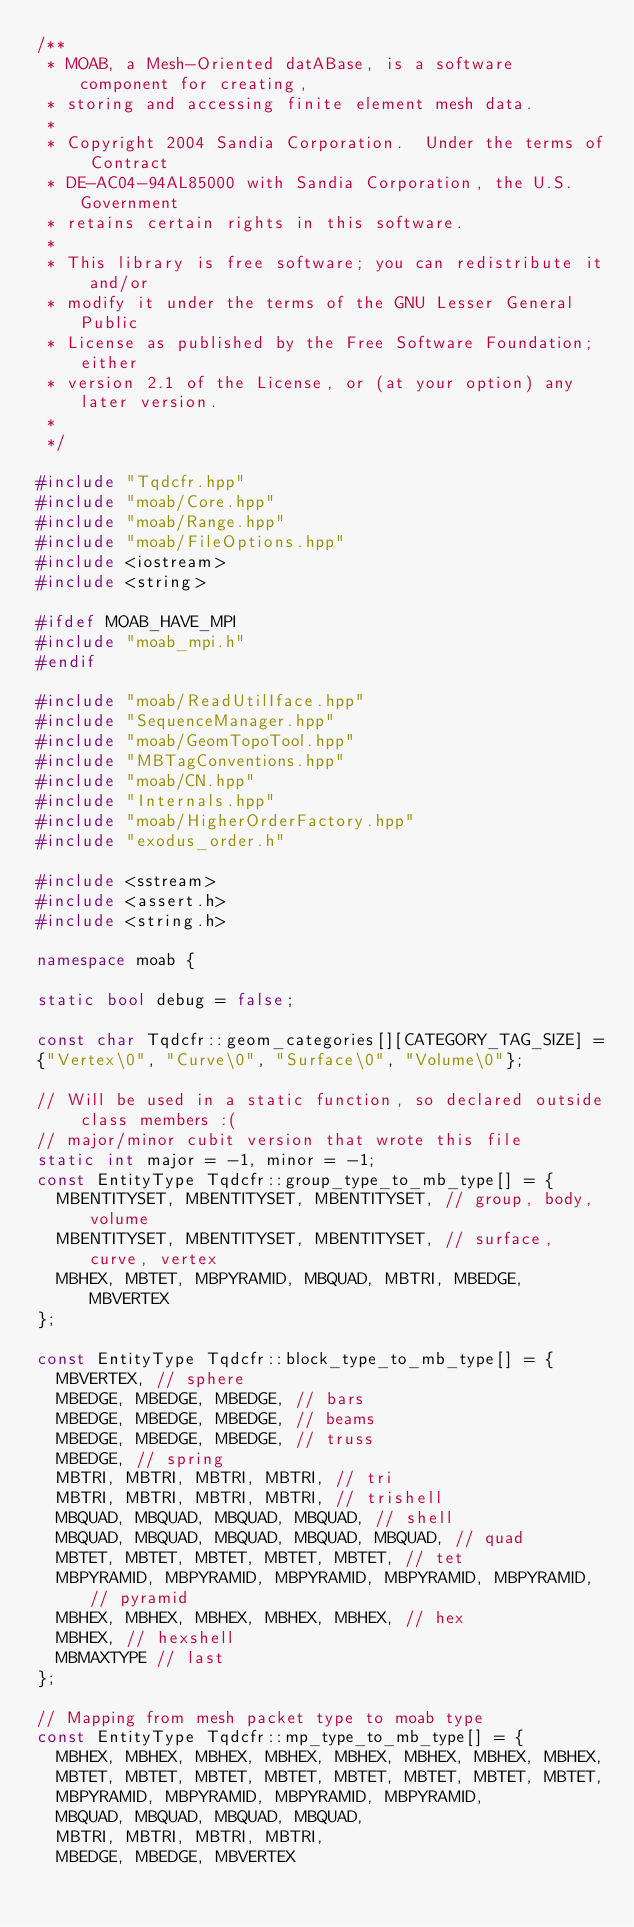<code> <loc_0><loc_0><loc_500><loc_500><_C++_>/**
 * MOAB, a Mesh-Oriented datABase, is a software component for creating,
 * storing and accessing finite element mesh data.
 * 
 * Copyright 2004 Sandia Corporation.  Under the terms of Contract
 * DE-AC04-94AL85000 with Sandia Corporation, the U.S. Government
 * retains certain rights in this software.
 * 
 * This library is free software; you can redistribute it and/or
 * modify it under the terms of the GNU Lesser General Public
 * License as published by the Free Software Foundation; either
 * version 2.1 of the License, or (at your option) any later version.
 * 
 */

#include "Tqdcfr.hpp"
#include "moab/Core.hpp"
#include "moab/Range.hpp"
#include "moab/FileOptions.hpp"
#include <iostream>
#include <string>

#ifdef MOAB_HAVE_MPI
#include "moab_mpi.h"
#endif

#include "moab/ReadUtilIface.hpp"
#include "SequenceManager.hpp"
#include "moab/GeomTopoTool.hpp"
#include "MBTagConventions.hpp"
#include "moab/CN.hpp"
#include "Internals.hpp"
#include "moab/HigherOrderFactory.hpp"
#include "exodus_order.h"

#include <sstream>
#include <assert.h>
#include <string.h>

namespace moab {

static bool debug = false;

const char Tqdcfr::geom_categories[][CATEGORY_TAG_SIZE] =
{"Vertex\0", "Curve\0", "Surface\0", "Volume\0"};

// Will be used in a static function, so declared outside class members :(
// major/minor cubit version that wrote this file
static int major = -1, minor = -1;
const EntityType Tqdcfr::group_type_to_mb_type[] = {
  MBENTITYSET, MBENTITYSET, MBENTITYSET, // group, body, volume
  MBENTITYSET, MBENTITYSET, MBENTITYSET, // surface, curve, vertex
  MBHEX, MBTET, MBPYRAMID, MBQUAD, MBTRI, MBEDGE, MBVERTEX
};

const EntityType Tqdcfr::block_type_to_mb_type[] = {
  MBVERTEX, // sphere
  MBEDGE, MBEDGE, MBEDGE, // bars
  MBEDGE, MBEDGE, MBEDGE, // beams
  MBEDGE, MBEDGE, MBEDGE, // truss
  MBEDGE, // spring
  MBTRI, MBTRI, MBTRI, MBTRI, // tri
  MBTRI, MBTRI, MBTRI, MBTRI, // trishell
  MBQUAD, MBQUAD, MBQUAD, MBQUAD, // shell
  MBQUAD, MBQUAD, MBQUAD, MBQUAD, MBQUAD, // quad
  MBTET, MBTET, MBTET, MBTET, MBTET, // tet
  MBPYRAMID, MBPYRAMID, MBPYRAMID, MBPYRAMID, MBPYRAMID, // pyramid
  MBHEX, MBHEX, MBHEX, MBHEX, MBHEX, // hex
  MBHEX, // hexshell
  MBMAXTYPE // last
};

// Mapping from mesh packet type to moab type
const EntityType Tqdcfr::mp_type_to_mb_type[] = {
  MBHEX, MBHEX, MBHEX, MBHEX, MBHEX, MBHEX, MBHEX, MBHEX, 
  MBTET, MBTET, MBTET, MBTET, MBTET, MBTET, MBTET, MBTET, 
  MBPYRAMID, MBPYRAMID, MBPYRAMID, MBPYRAMID, 
  MBQUAD, MBQUAD, MBQUAD, MBQUAD, 
  MBTRI, MBTRI, MBTRI, MBTRI, 
  MBEDGE, MBEDGE, MBVERTEX</code> 